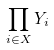<formula> <loc_0><loc_0><loc_500><loc_500>\prod _ { i \in X } Y _ { i }</formula> 